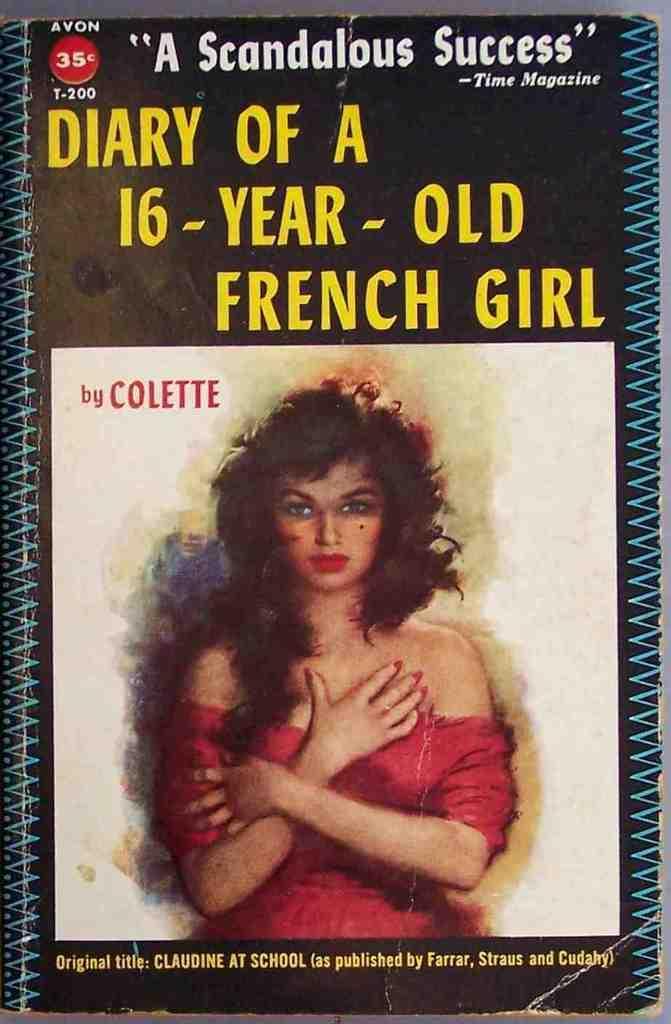In one or two sentences, can you explain what this image depicts? In this picture, we see the painting of the woman who is wearing the red dress. At the top and at the bottom, we see some text written. In the background, it is in white and black color. This picture might be a book or a poster. 